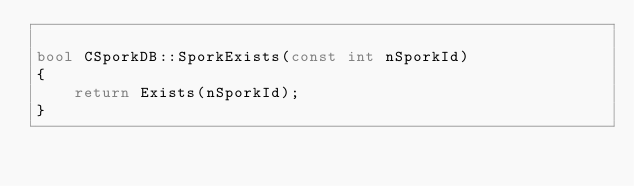<code> <loc_0><loc_0><loc_500><loc_500><_C++_>
bool CSporkDB::SporkExists(const int nSporkId)
{
    return Exists(nSporkId);
}
</code> 